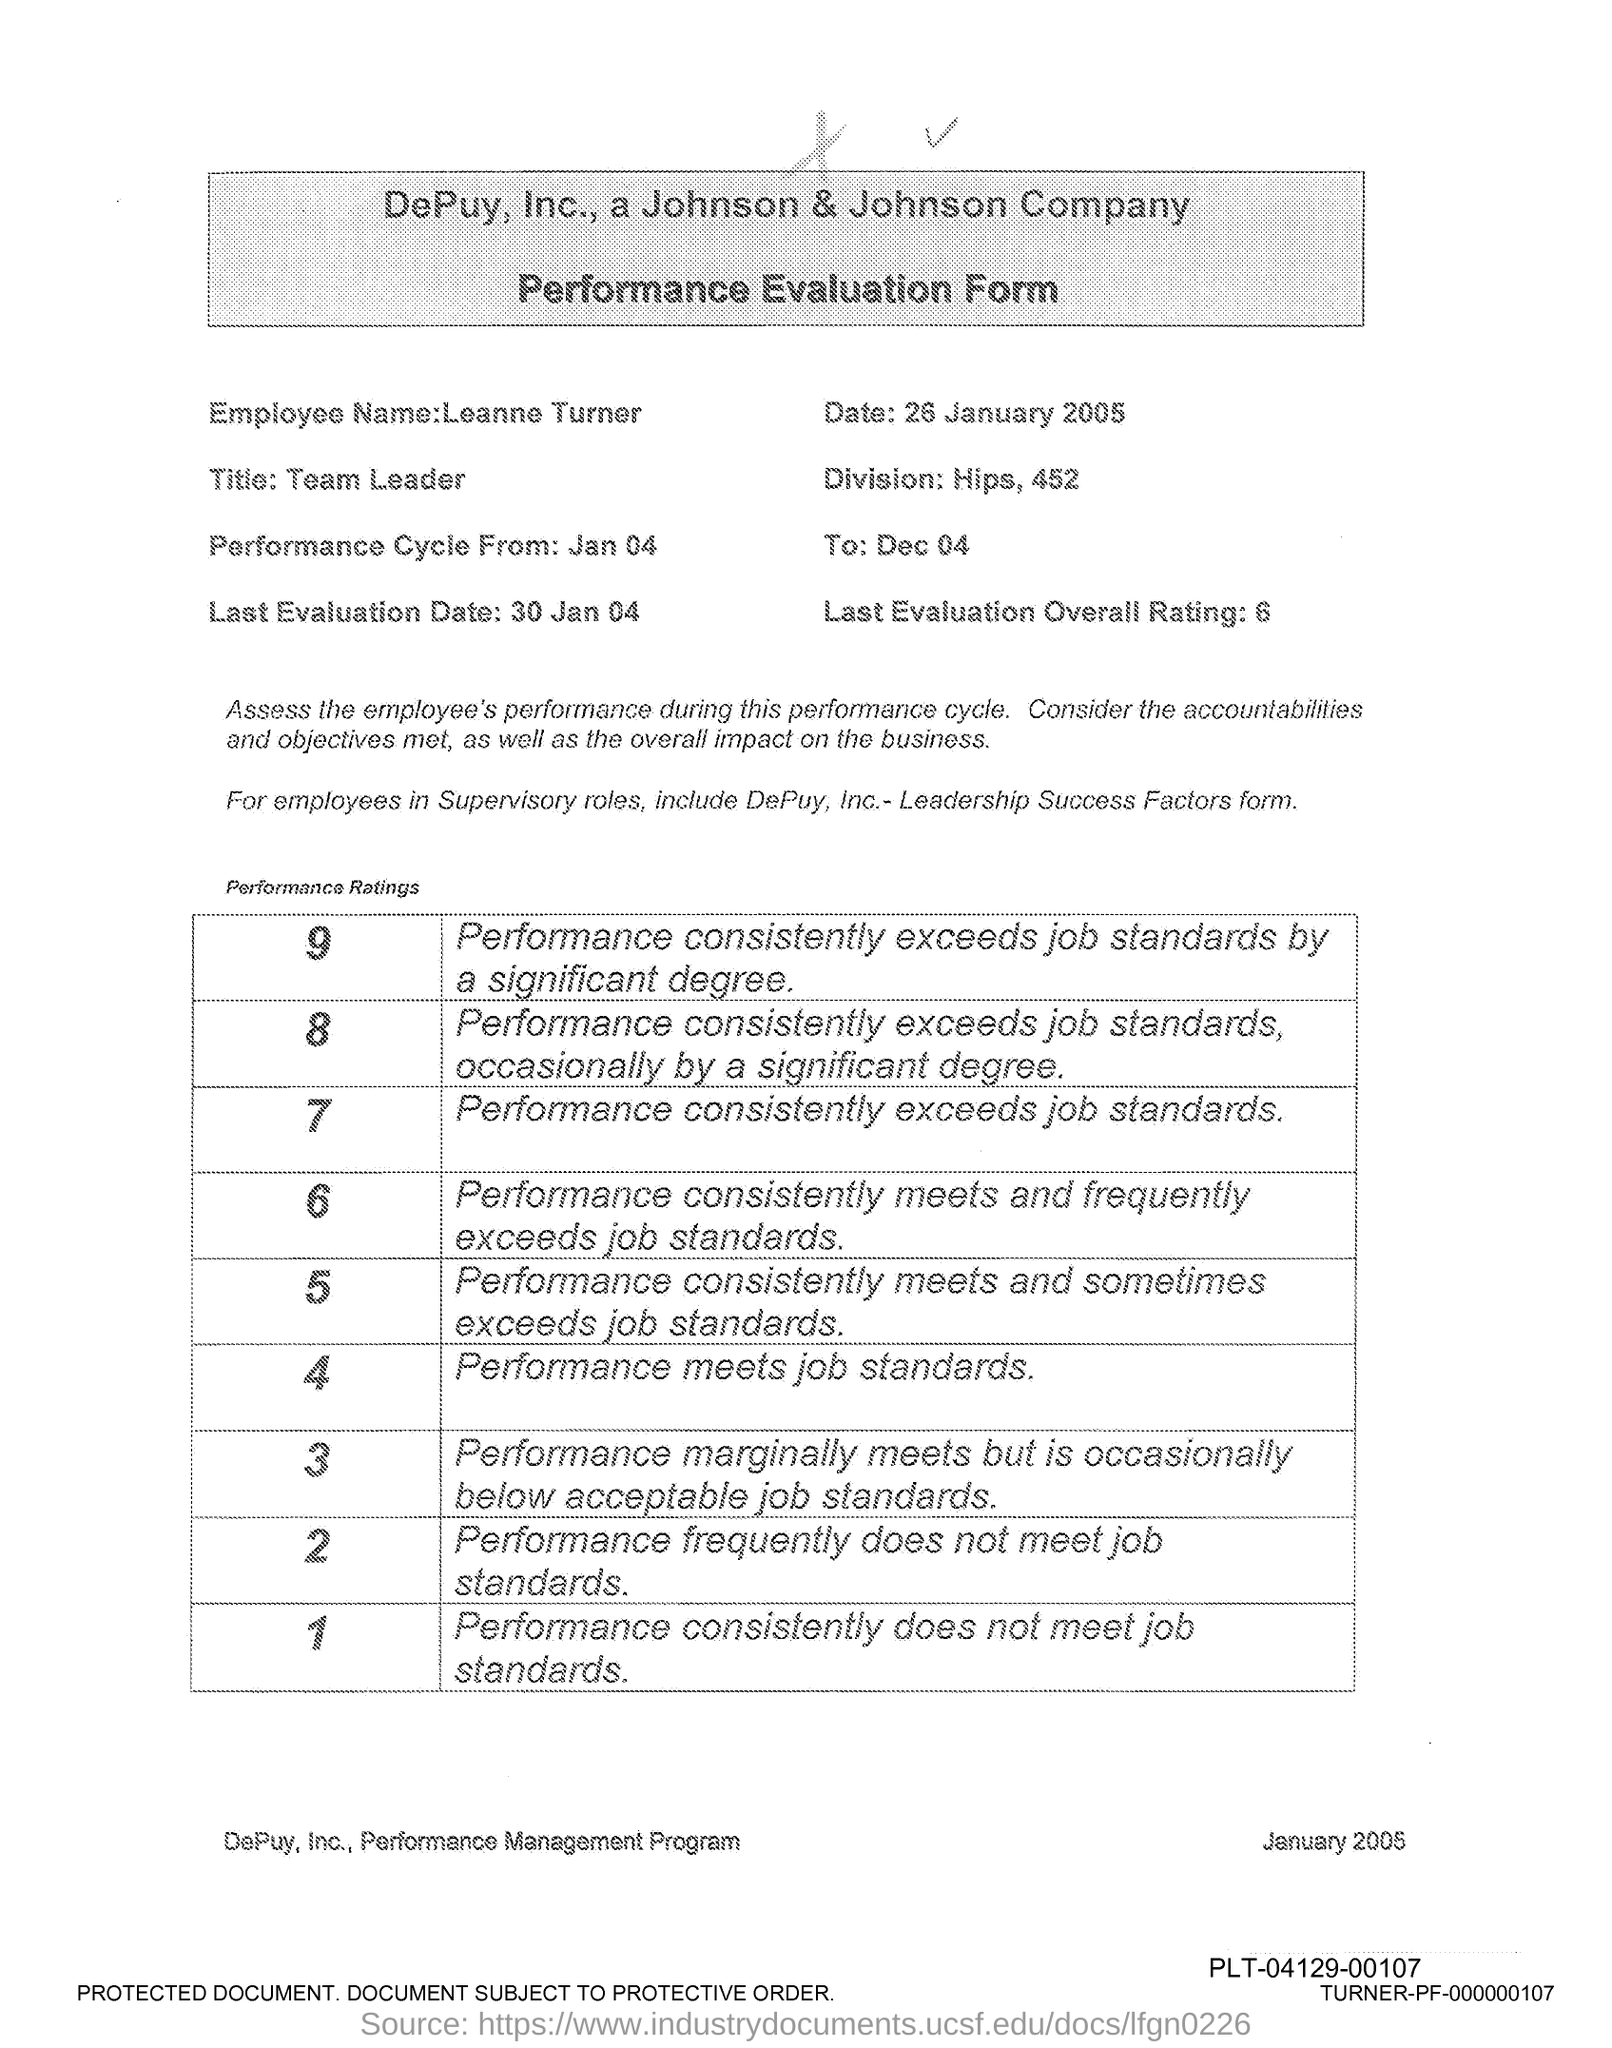Draw attention to some important aspects in this diagram. It is the name of the employee Leanne Turner. 